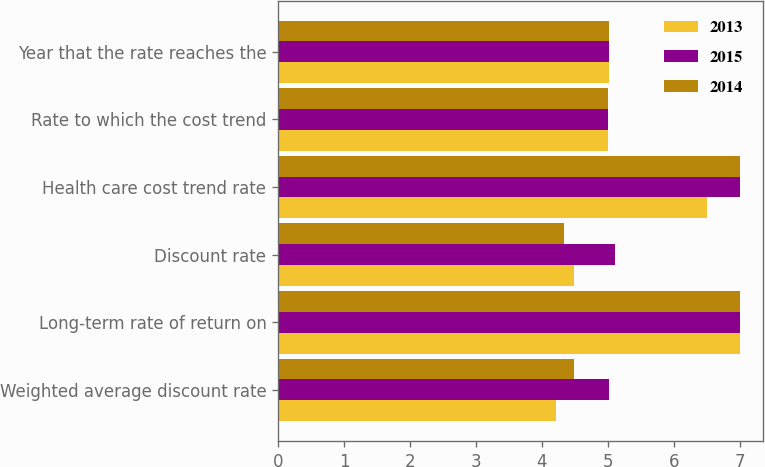<chart> <loc_0><loc_0><loc_500><loc_500><stacked_bar_chart><ecel><fcel>Weighted average discount rate<fcel>Long-term rate of return on<fcel>Discount rate<fcel>Health care cost trend rate<fcel>Rate to which the cost trend<fcel>Year that the rate reaches the<nl><fcel>2013<fcel>4.22<fcel>7<fcel>4.49<fcel>6.5<fcel>5<fcel>5.02<nl><fcel>2015<fcel>5.02<fcel>7<fcel>5.11<fcel>7<fcel>5<fcel>5.02<nl><fcel>2014<fcel>4.49<fcel>7<fcel>4.34<fcel>7<fcel>5<fcel>5.02<nl></chart> 